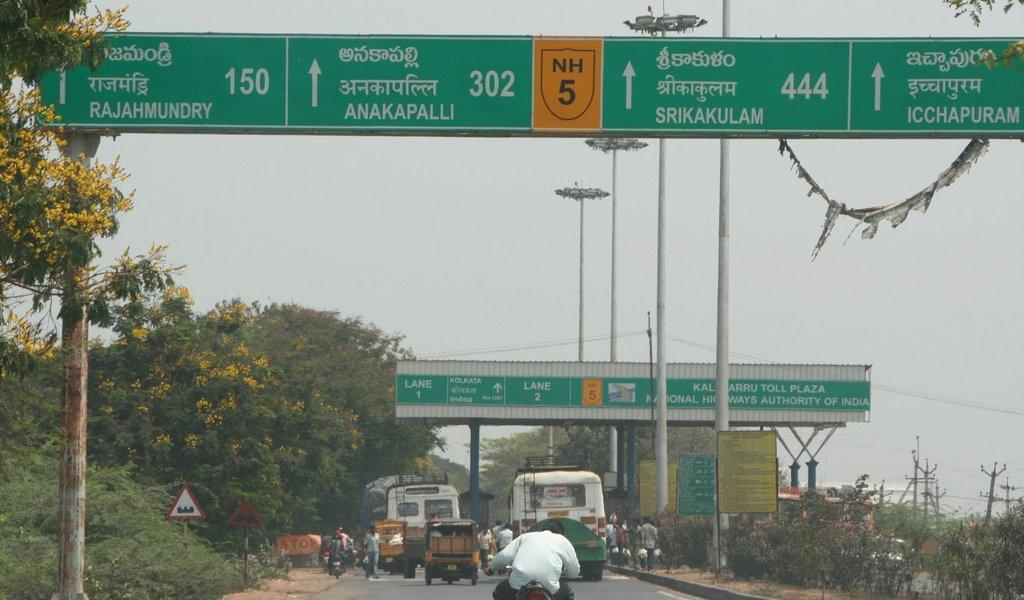<image>
Present a compact description of the photo's key features. The Toll Plaza has a lane 1 and a lane 2. 